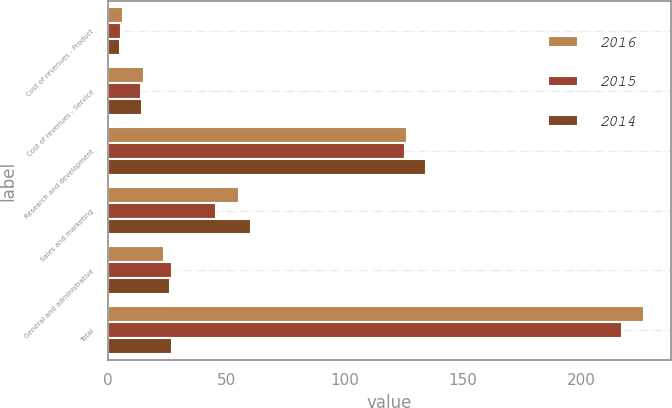Convert chart to OTSL. <chart><loc_0><loc_0><loc_500><loc_500><stacked_bar_chart><ecel><fcel>Cost of revenues - Product<fcel>Cost of revenues - Service<fcel>Research and development<fcel>Sales and marketing<fcel>General and administrative<fcel>Total<nl><fcel>2016<fcel>6.4<fcel>15.3<fcel>126.5<fcel>55.2<fcel>23.4<fcel>226.8<nl><fcel>2015<fcel>5.6<fcel>13.8<fcel>125.4<fcel>45.6<fcel>26.9<fcel>217.3<nl><fcel>2014<fcel>5<fcel>14.2<fcel>134.5<fcel>60.2<fcel>26.1<fcel>26.9<nl></chart> 